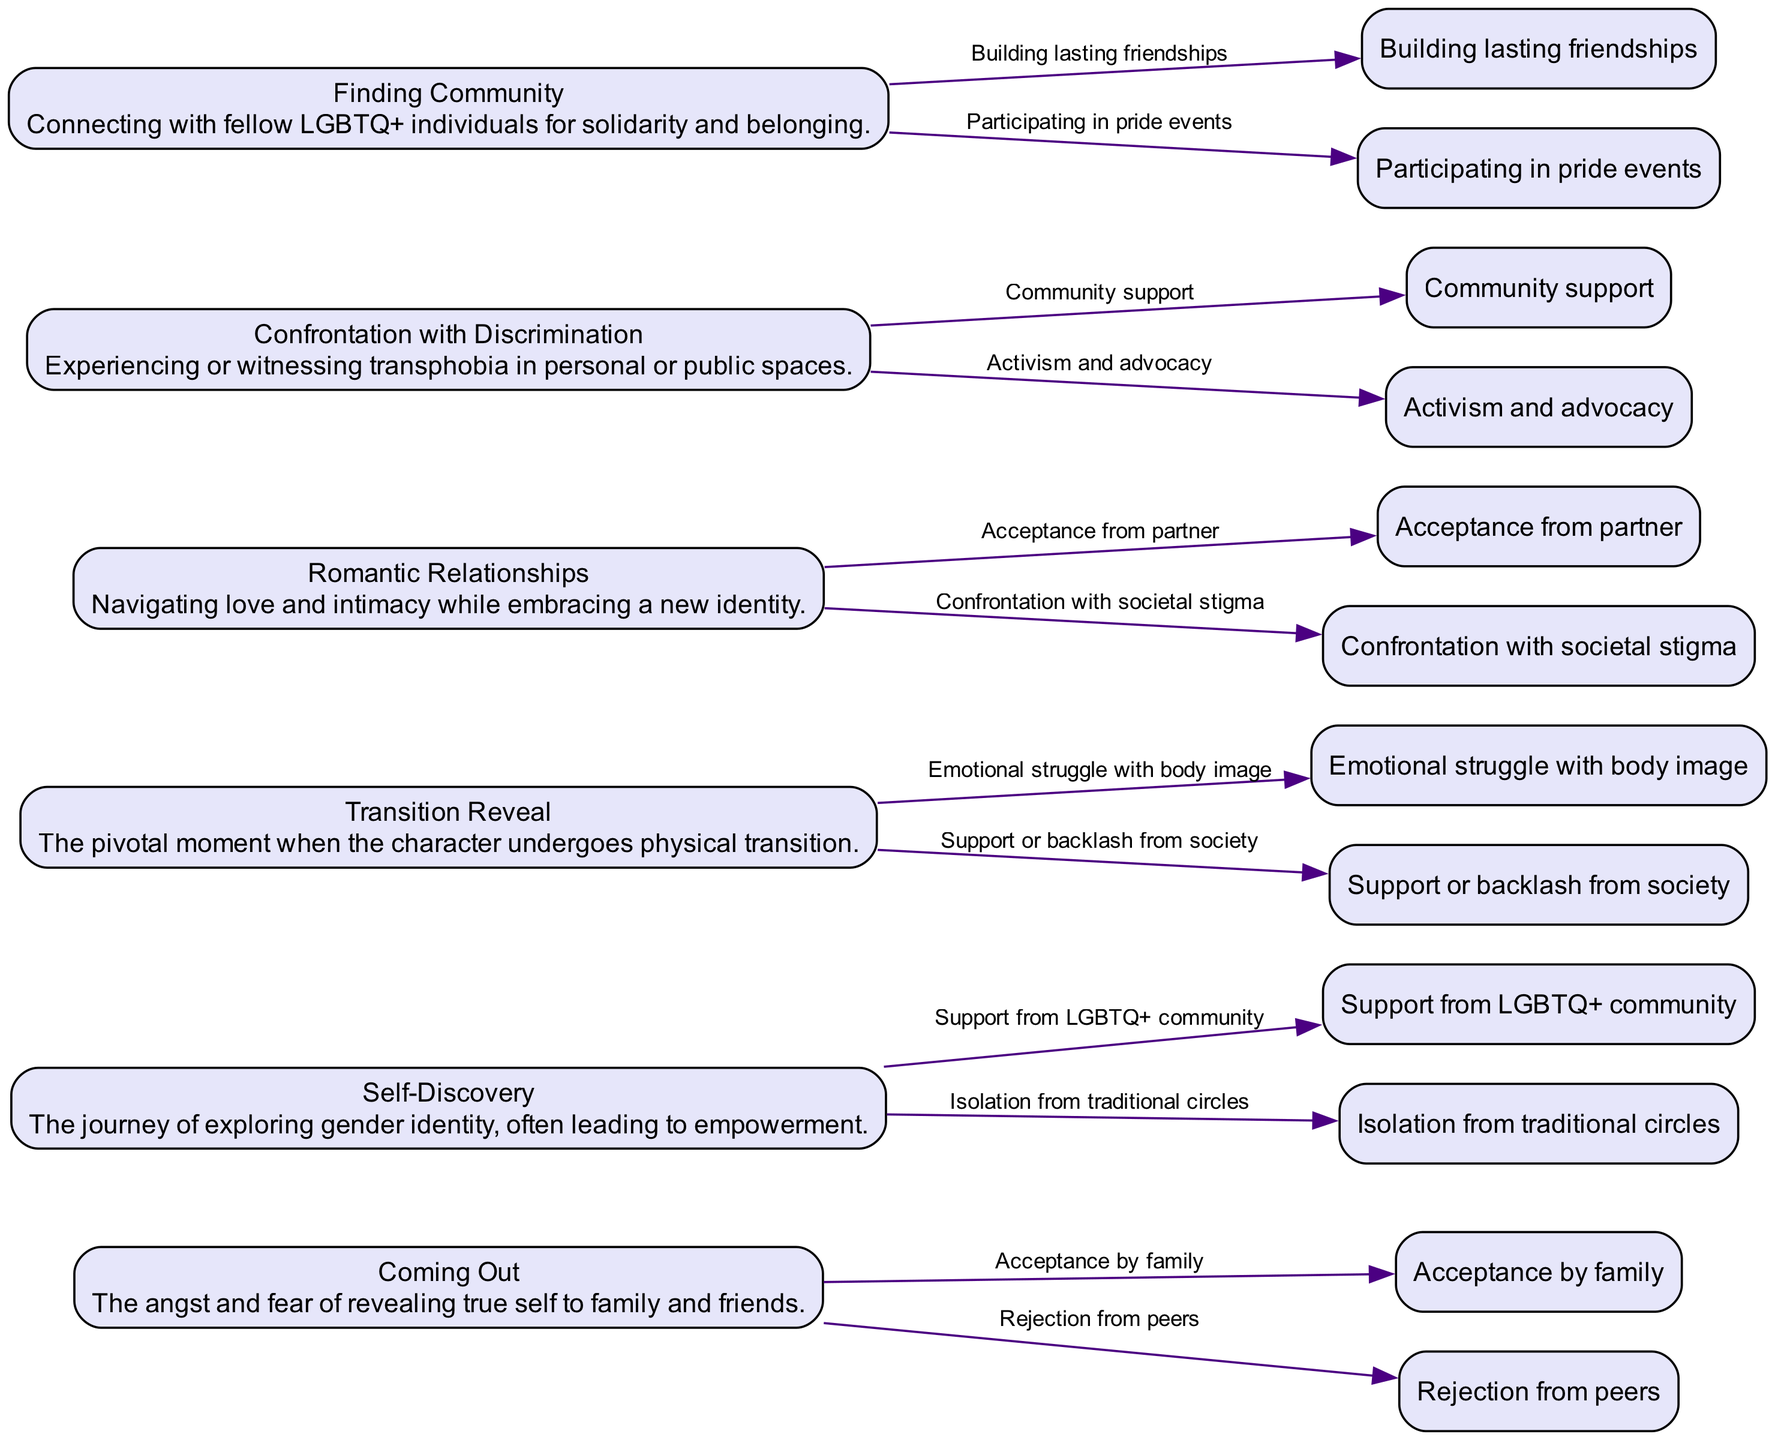What is the first emotional moment listed in the diagram? The first emotional moment is the one that appears at the top or to the leftmost position in a directed graph. In this case, "Coming Out" is the first moment mentioned in the provided data.
Answer: Coming Out How many next steps are there for "Transition Reveal"? To answer this, we look at the "Transition Reveal" node in the diagram and count its outgoing edges to the next steps. According to the data, there are two next steps listed for this moment.
Answer: 2 What emotional moment leads to "Finding Community"? We can determine the relationship between nodes by following the edges. The emotional moment that connects directly to "Finding Community" is "Confrontation with Discrimination," as it mentions support leading to community.
Answer: Confrontation with Discrimination What is the emotional moment associated with experiencing transphobia? By examining the descriptions of each moment, "Confrontation with Discrimination" specifically addresses experiencing or witnessing transphobia. Thus, it is the moment associated with this experience.
Answer: Confrontation with Discrimination Which emotional moment has the next step "Support from LGBTQ+ community"? To find this, we can check which moment lists "Support from LGBTQ+ community" as one of its next steps. It is the "Self-Discovery" moment, as indicated in the data.
Answer: Self-Discovery What is the last emotional moment listed? The last emotional moment is the one that appears at the bottom or rightmost position of the directed graph. According to the provided data, "Finding Community" is the last moment mentioned.
Answer: Finding Community How many total emotional moments are represented in the diagram? The total number of emotional moments can be identified by counting the nodes depicted in the diagram. Based on the data, there are six distinct emotional moments.
Answer: 6 Which two emotional moments involve romantic relationships? To determine this, we can check the nodes to see which moments are related to romantic contexts. "Romantic Relationships" and "Transition Reveal" both specifically mention relationships in their context.
Answer: Romantic Relationships, Transition Reveal Which next step follows after "Acceptance by family"? We look for the emotional moment that includes "Acceptance by family" and examine its next steps. "Coming Out" is the moment associated with this acceptance, and its next step is "Rejection from peers."
Answer: Rejection from peers 